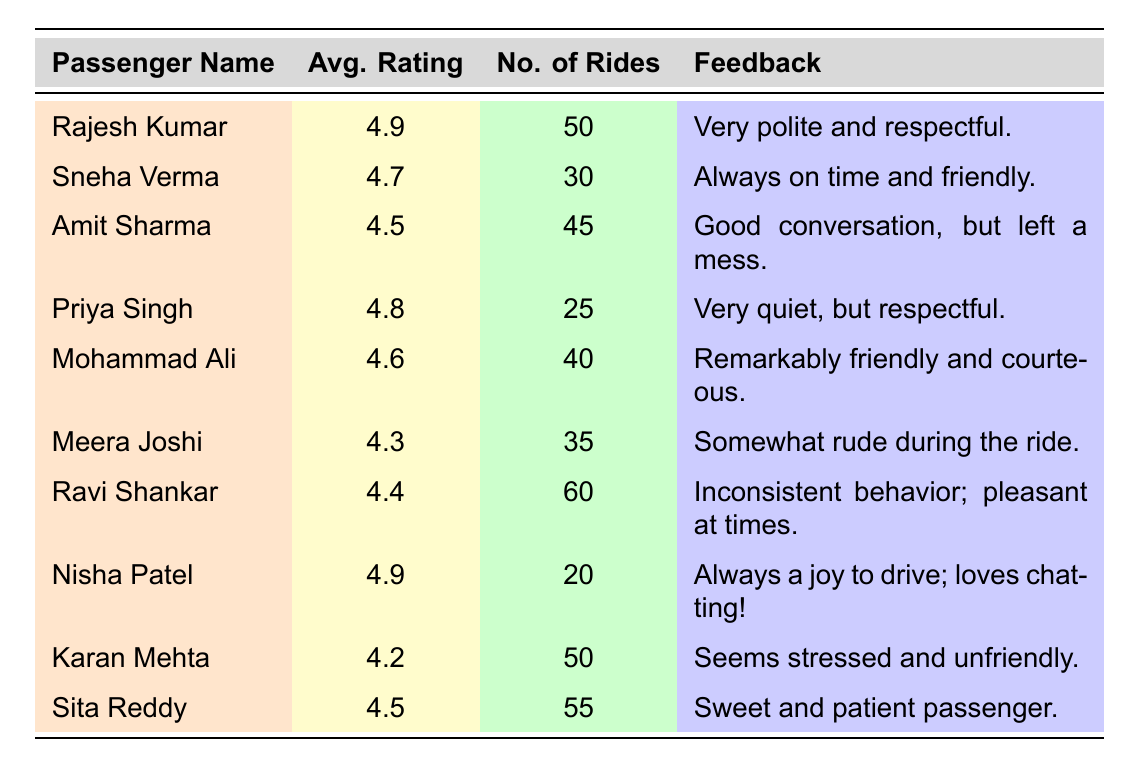What is the average rating of Rajesh Kumar? The table shows that Rajesh Kumar has an average rating of 4.9.
Answer: 4.9 How many rides did Sneha Verma take? By looking at the table, Sneha Verma took 30 rides.
Answer: 30 Which passenger has the lowest average rating? The table indicates Karan Mehta has the lowest average rating of 4.2.
Answer: Karan Mehta What is the average rating of passengers who took more than 40 rides? Calculate the average for the passengers with more than 40 rides: (4.9 + 4.5 + 4.6 + 4.4 + 4.5) = 22.9, and there are 5 passengers. Thus, the average is 22.9 / 5 = 4.58.
Answer: 4.58 Did any passengers give feedback about being friendly? Yes, both Sneha Verma and Mohammad Ali received comments mentioning their friendliness.
Answer: Yes How many rides did Nisha Patel take compared to Priya Singh? Nisha Patel took 20 rides, while Priya Singh took 25 rides. The difference is 25 - 20 = 5 rides.
Answer: 5 rides What is the combined average rating of passengers with ratings above 4.5? The average ratings above 4.5 are 4.9 (Rajesh Kumar), 4.7 (Sneha Verma), 4.8 (Priya Singh), 4.6 (Mohammad Ali), and 4.5 (Sita Reddy). Their sum is 24.5, and there are 5 passengers, so the average is 24.5 / 5 = 4.9.
Answer: 4.9 Is Meera Joshi rated higher than Ravi Shankar? Meera Joshi has an average rating of 4.3, while Ravi Shankar has a rating of 4.4, so Meera Joshi is not rated higher.
Answer: No What feedback did the passenger with the most rides receive? Ravi Shankar, who took 60 rides, received feedback stating he has "inconsistent behavior; pleasant at times."
Answer: Inconsistent behavior; pleasant at times Which two passengers have the same average rating? Amit Sharma and Sita Reddy both have an average rating of 4.5.
Answer: Amit Sharma and Sita Reddy 